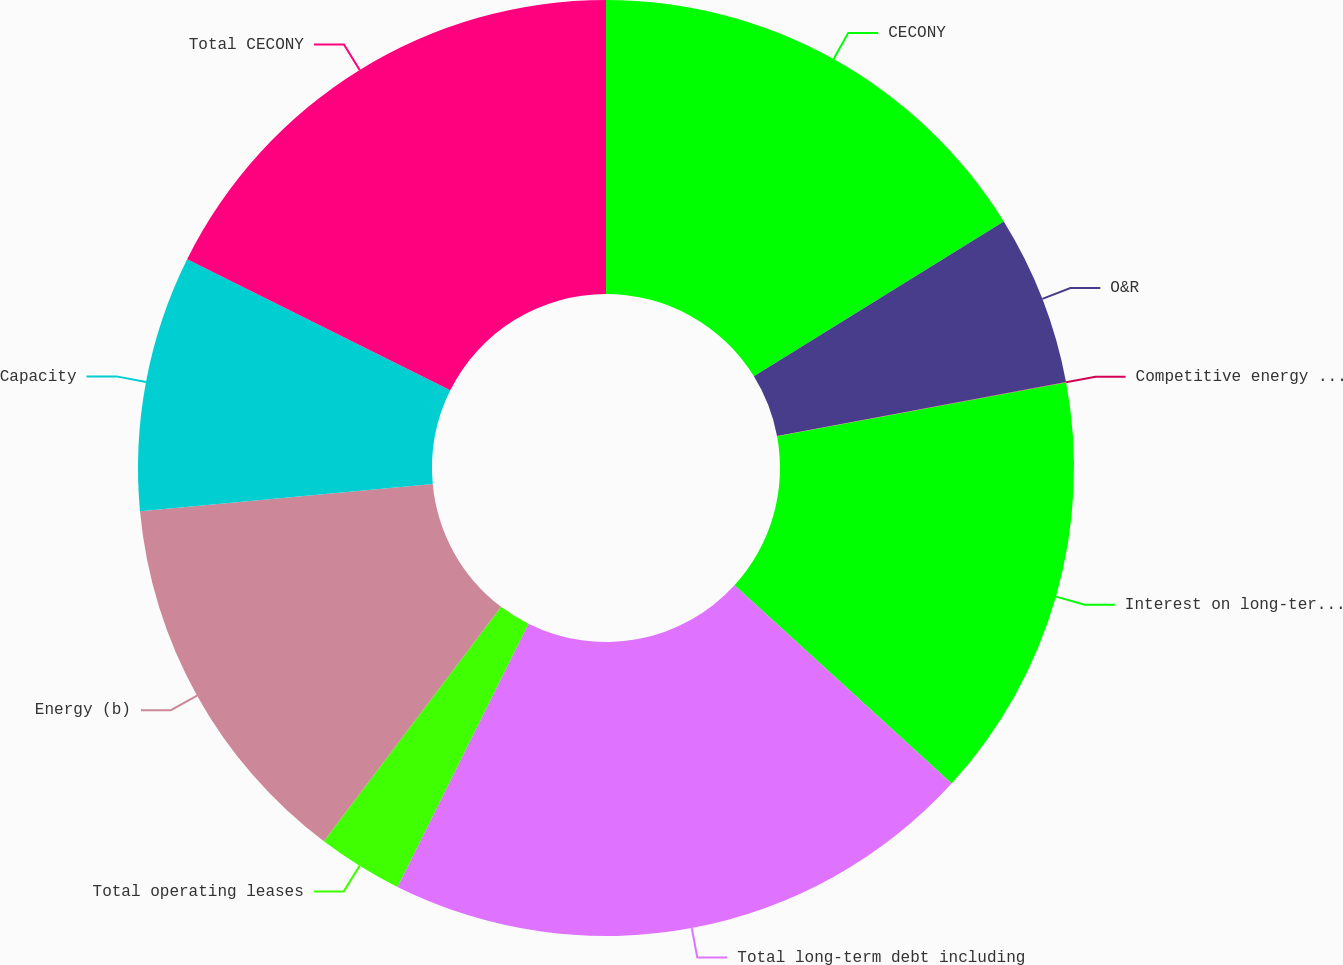Convert chart. <chart><loc_0><loc_0><loc_500><loc_500><pie_chart><fcel>CECONY<fcel>O&R<fcel>Competitive energy businesses<fcel>Interest on long-term debt (a)<fcel>Total long-term debt including<fcel>Total operating leases<fcel>Energy (b)<fcel>Capacity<fcel>Total CECONY<nl><fcel>16.17%<fcel>5.89%<fcel>0.02%<fcel>14.7%<fcel>20.57%<fcel>2.95%<fcel>13.23%<fcel>8.83%<fcel>17.64%<nl></chart> 